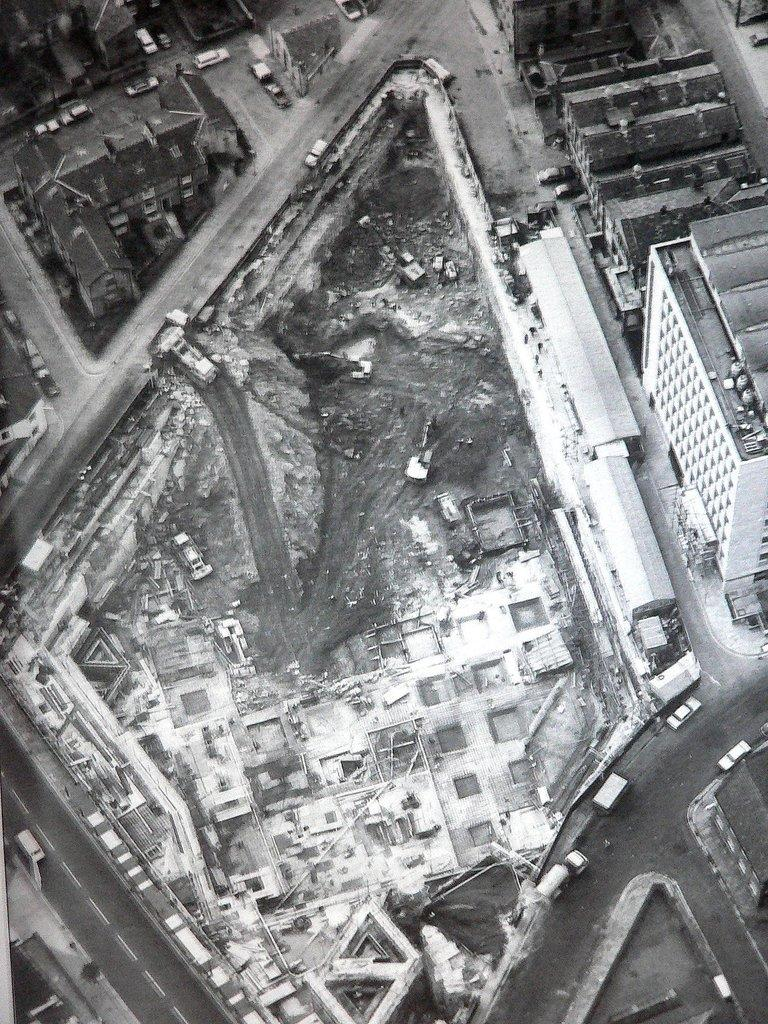What type of infrastructure can be seen in the image? There are roads in the image. What is happening on the roads? There are vehicles moving on the roads. What else can be seen in the image besides the roads and vehicles? There are buildings visible in the image. Can you tell me how many streams are visible in the image? There are no streams visible in the image; it features roads, vehicles, and buildings. What type of operation is being performed on the truck in the image? There is no truck present in the image, and therefore no operation can be observed. 